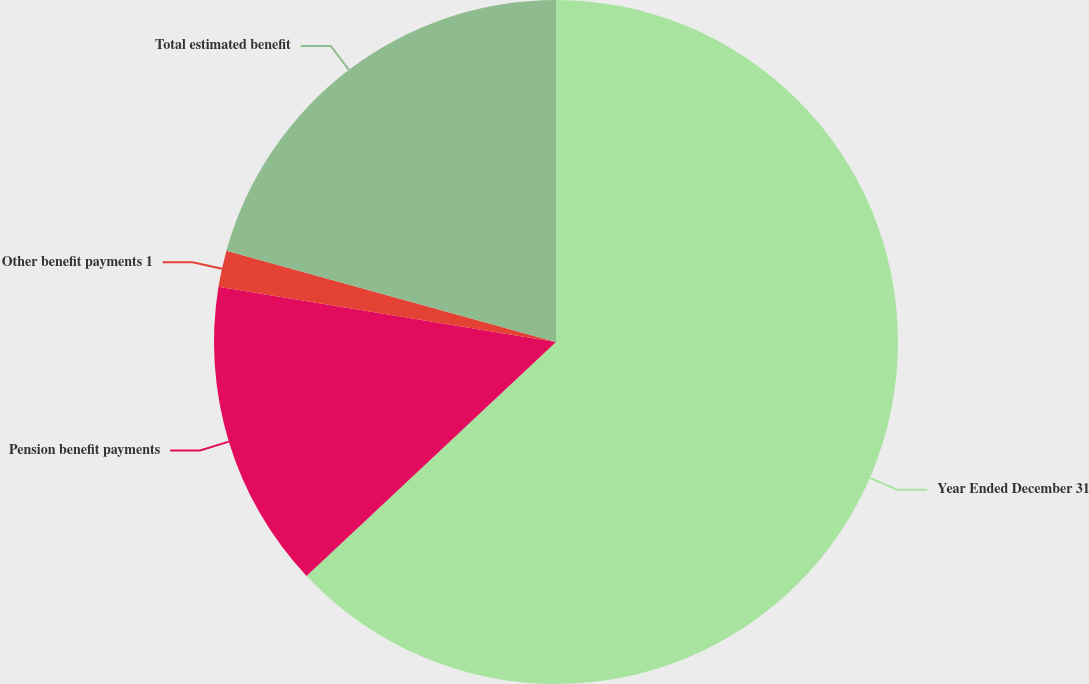Convert chart. <chart><loc_0><loc_0><loc_500><loc_500><pie_chart><fcel>Year Ended December 31<fcel>Pension benefit payments<fcel>Other benefit payments 1<fcel>Total estimated benefit<nl><fcel>63.01%<fcel>14.57%<fcel>1.72%<fcel>20.7%<nl></chart> 